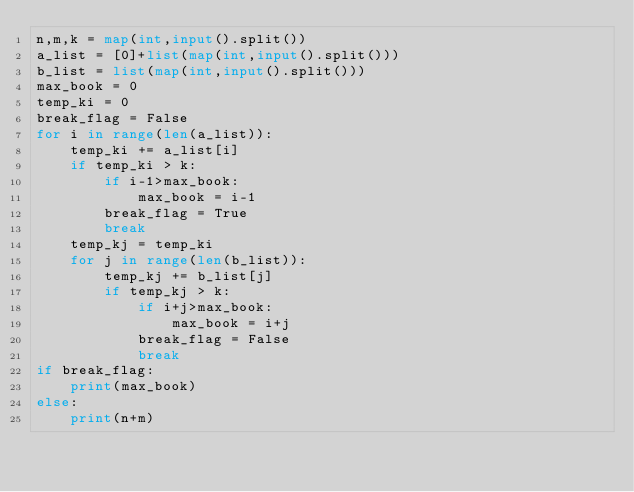Convert code to text. <code><loc_0><loc_0><loc_500><loc_500><_Python_>n,m,k = map(int,input().split())
a_list = [0]+list(map(int,input().split()))
b_list = list(map(int,input().split()))
max_book = 0
temp_ki = 0
break_flag = False
for i in range(len(a_list)):
    temp_ki += a_list[i]
    if temp_ki > k:
        if i-1>max_book:
            max_book = i-1
        break_flag = True
        break
    temp_kj = temp_ki
    for j in range(len(b_list)):
        temp_kj += b_list[j]
        if temp_kj > k:
            if i+j>max_book:
                max_book = i+j
            break_flag = False
            break
if break_flag:
    print(max_book)
else:
    print(n+m)</code> 